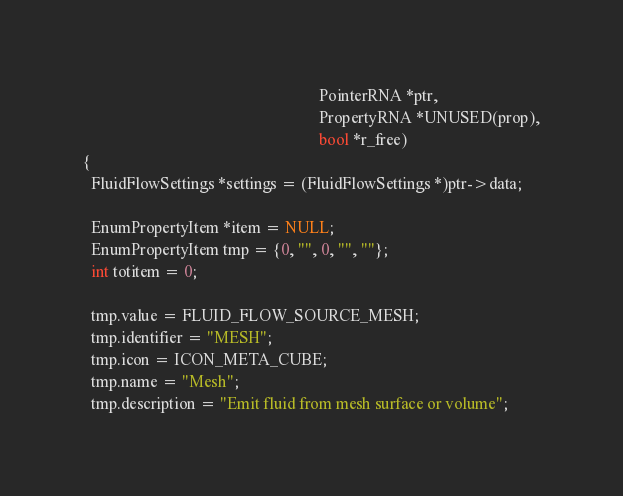<code> <loc_0><loc_0><loc_500><loc_500><_C_>                                                          PointerRNA *ptr,
                                                          PropertyRNA *UNUSED(prop),
                                                          bool *r_free)
{
  FluidFlowSettings *settings = (FluidFlowSettings *)ptr->data;

  EnumPropertyItem *item = NULL;
  EnumPropertyItem tmp = {0, "", 0, "", ""};
  int totitem = 0;

  tmp.value = FLUID_FLOW_SOURCE_MESH;
  tmp.identifier = "MESH";
  tmp.icon = ICON_META_CUBE;
  tmp.name = "Mesh";
  tmp.description = "Emit fluid from mesh surface or volume";</code> 